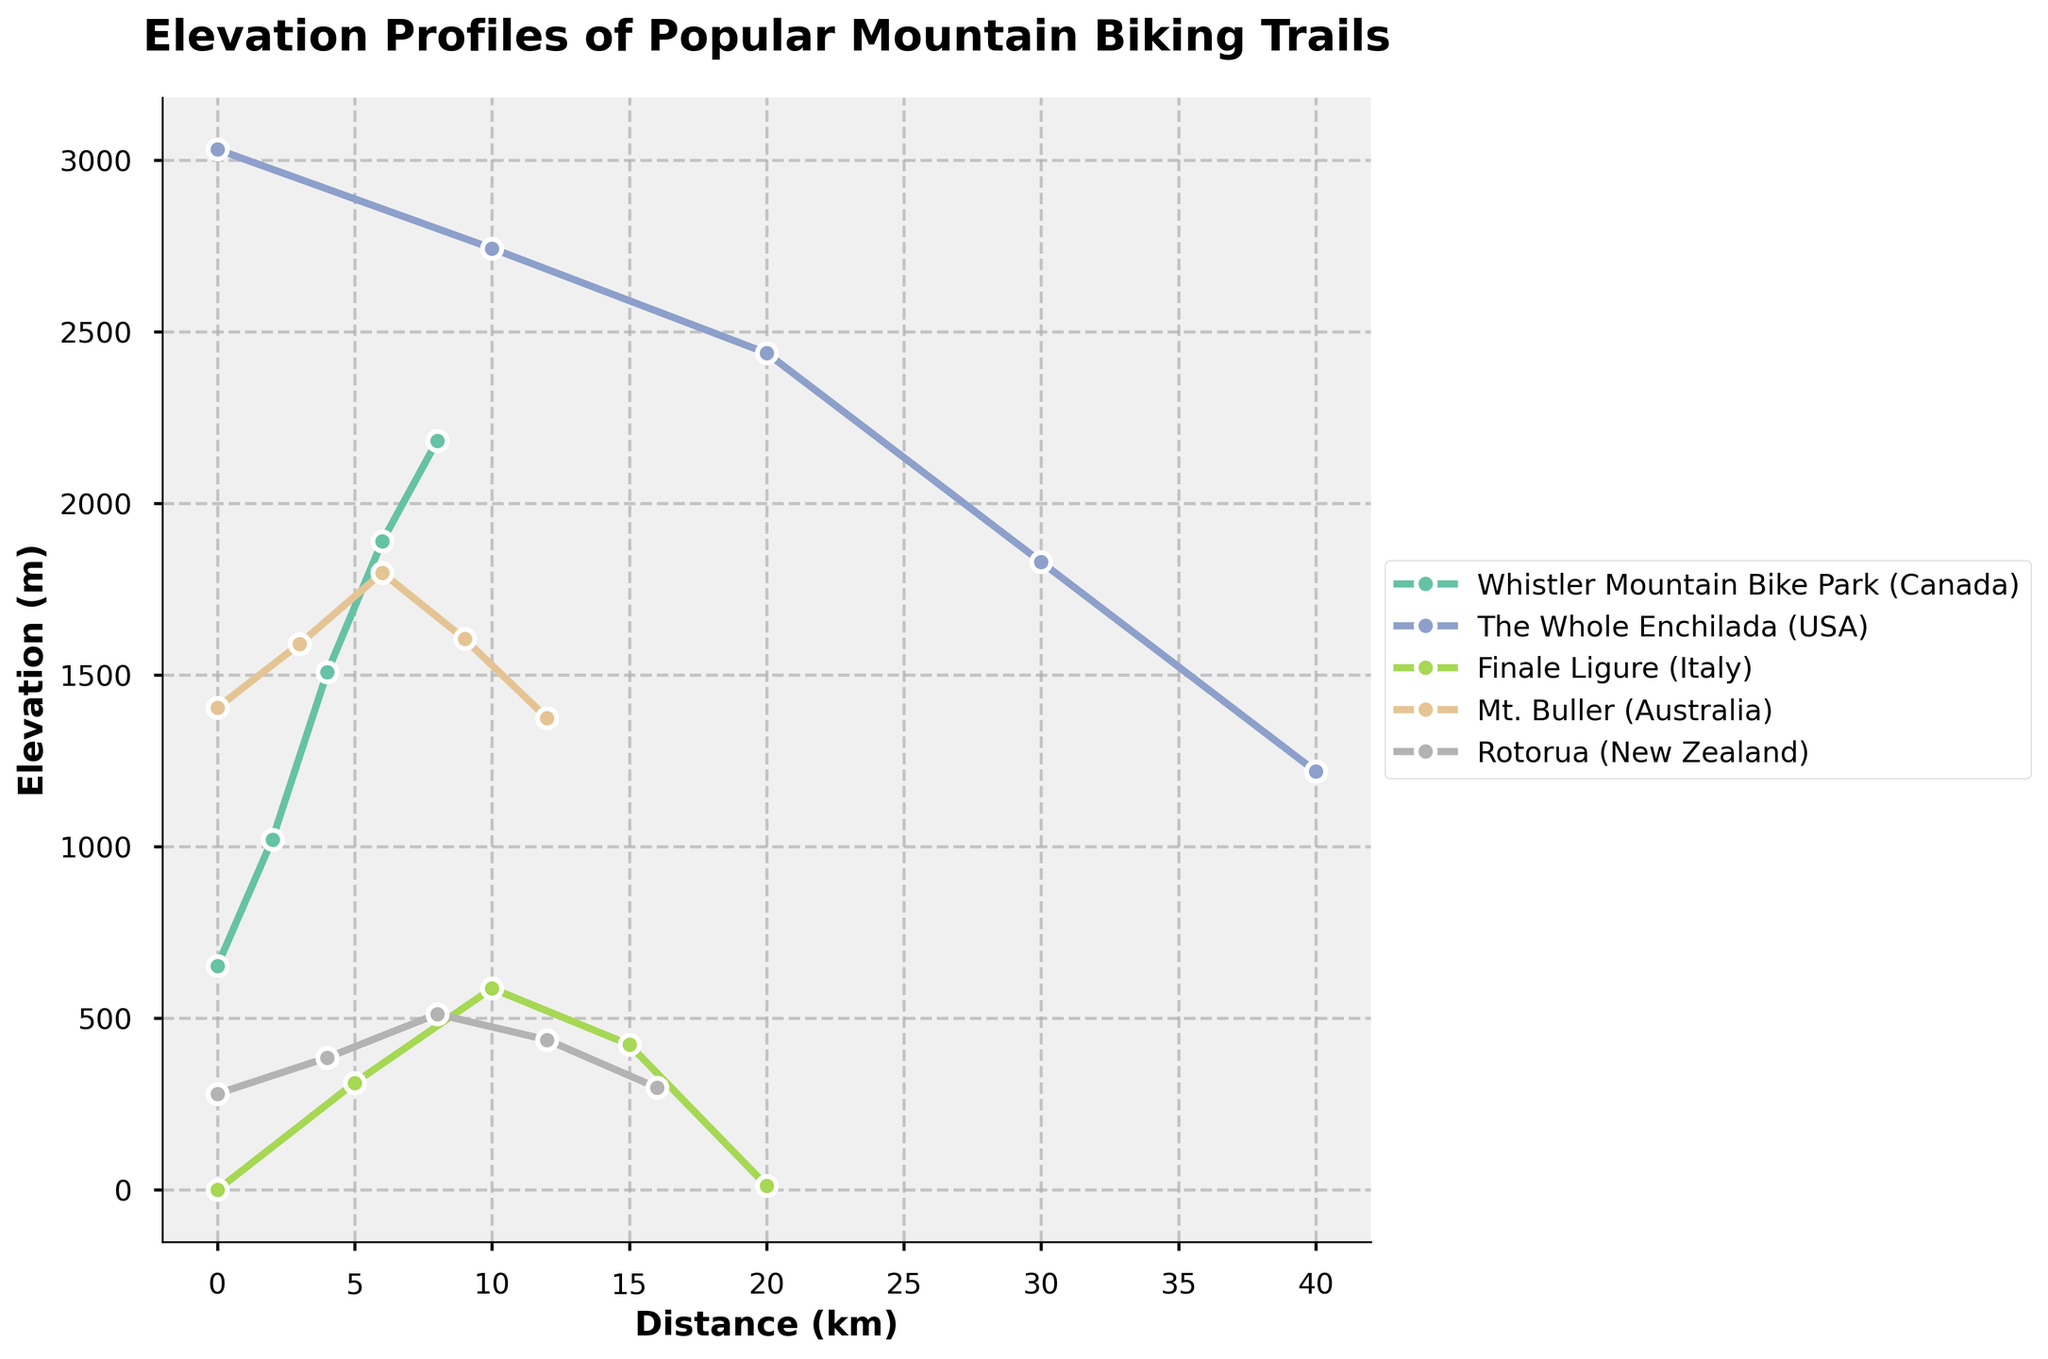What is the highest elevation gain in "Whistler Mountain Bike Park" over its distance? Observing the line for "Whistler Mountain Bike Park", the starting elevation is 653 meters, and the highest elevation is 2182 meters at the endpoint. Thus, the elevation gain is calculated as 2182 - 653 = 1529 meters.
Answer: 1529 meters Between "The Whole Enchilada" and "Mt. Buller", which trail has the higher starting elevation? Comparing the starting points of both trails, "The Whole Enchilada" starts at 3031 meters, whereas "Mt. Buller" starts at 1405 meters. Therefore, "The Whole Enchilada" has the higher starting elevation.
Answer: The Whole Enchilada What is the total elevation change for "Rotorua" from start to finish? "Rotorua" starts at 280 meters and ends at an elevation of 298 meters. The total elevation change is a minor increase calculated as 298 - 280 = 18 meters.
Answer: 18 meters Which trail shows the steepest descent? Looking at the chart, "The Whole Enchilada" has the most significant drop from 3031 meters to 1219 meters over a distance of 40 km, giving it a descent of 3031 - 1219 = 1812 meters. It thus has the steepest descent compared to other trails.
Answer: The Whole Enchilada What is the average elevation gain per kilometer for "Finale Ligure"? "Finale Ligure" starts at 0 meters and ends at 12 meters over a distance of 20 km, which implies a total elevation gain of 12 meters. The average gain per kilometer is 12 / 20 = 0.6 meters per kilometer.
Answer: 0.6 meters/km Which trail reaches its maximum elevation at the shortest distance? Reviewing the elevation profiles, "Whistler Mountain Bike Park" reaches 2182 meters at 8 km, "The Whole Enchilada" starts descending early, "Finale Ligure" and "Mt. Buller" reach lower elevations. Thus, "Whistler Mountain Bike Park" reaches its peak relatively quickly.
Answer: Whistler Mountain Bike Park Comparing "Mt. Buller" and "Rotorua", which has the greater elevation gain between its highest and lowest points? "Mt. Buller" has a highest elevation of 1798 meters and the lowest point of 1375 meters, thus an elevation gain of 1798 - 1375 = 423 meters. "Rotorua" hits 512 meters from a base of 280 meters, resulting in a gain of 512 - 280 = 232 meters. Therefore, Mt. Buller has the greater elevation gain.
Answer: Mt. Buller Which color line represents "The Whole Enchilada"? The color linked to "The Whole Enchilada" can be quickly identified in the legend box. Use the visual cue from the legend to identify the specific color line in the chart.
Answer: [The specific color from the legend] Is the final elevation of "Finale Ligure" greater, less than, or equal to its starting elevation? Observing the chart, the starting elevation for "Finale Ligure" is 0 meters, and it concludes at 12 meters, signifying that the final elevation is greater than the start elevation.
Answer: Greater 